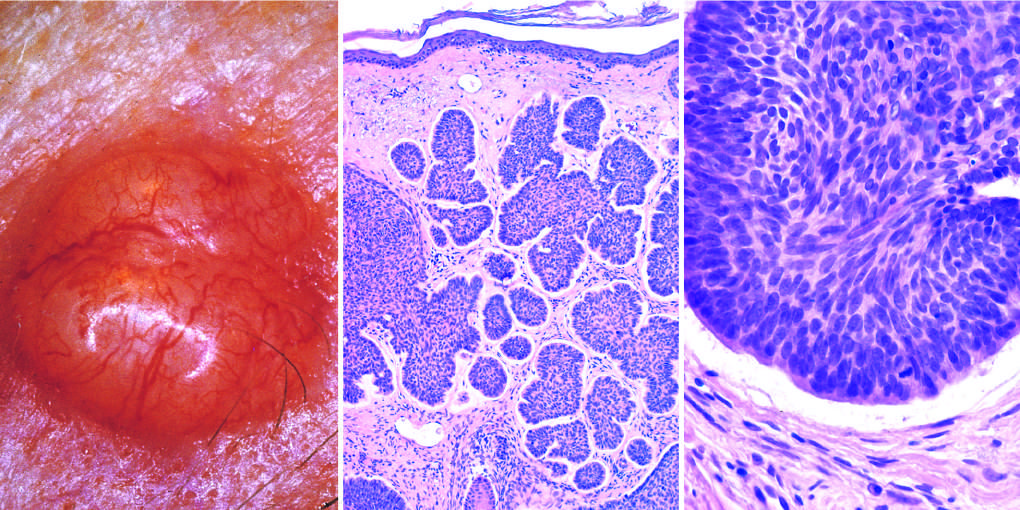s the cleft between the tumor cells and the stroma a highly characteristic artifact of sectioning?
Answer the question using a single word or phrase. Yes 